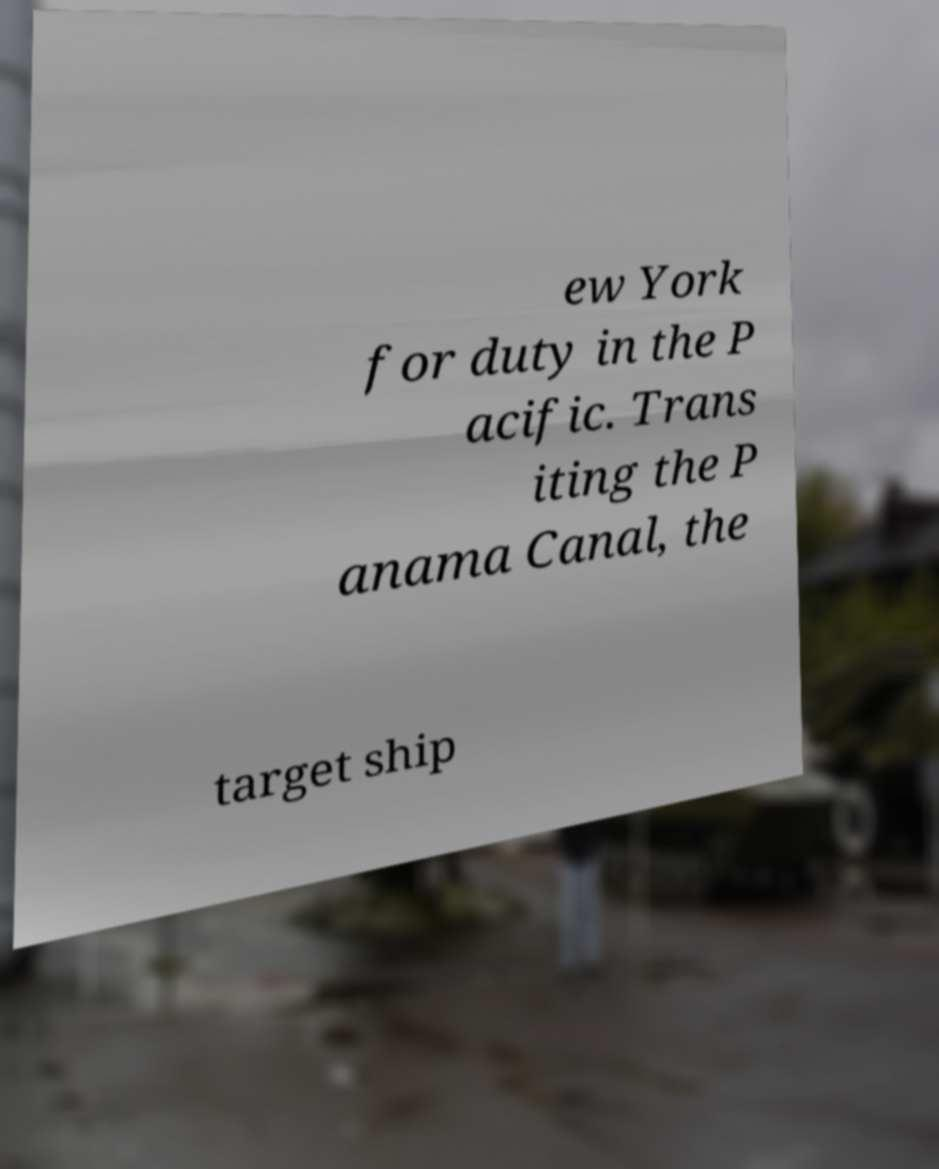For documentation purposes, I need the text within this image transcribed. Could you provide that? ew York for duty in the P acific. Trans iting the P anama Canal, the target ship 